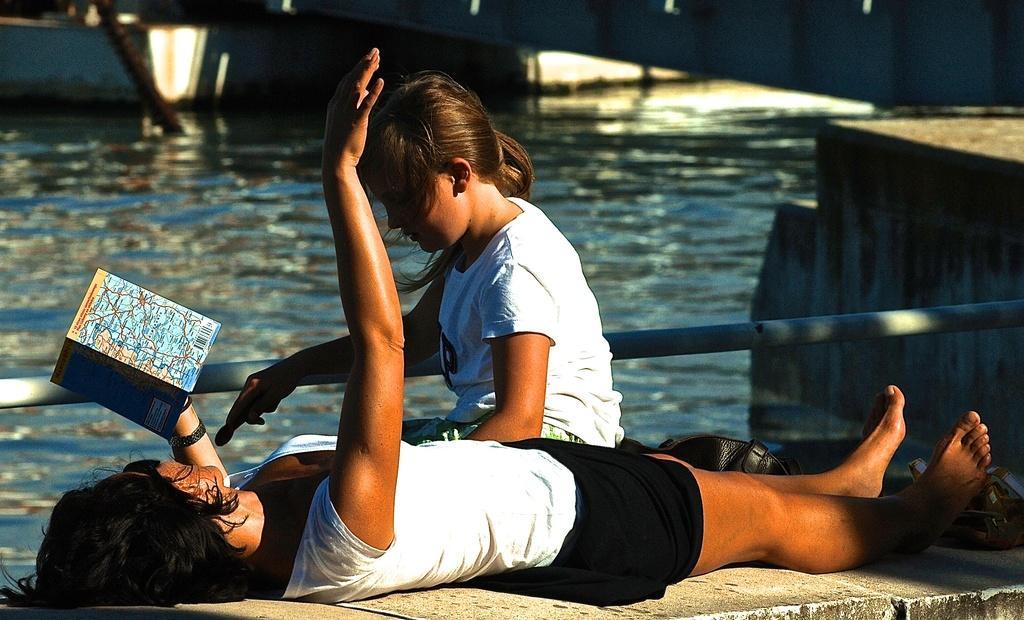Could you give a brief overview of what you see in this image? Bottom left side of the image a woman is laying on a wall and holding a book. In the middle of the image a girl is sitting. Behind her there is a fencing and water. 